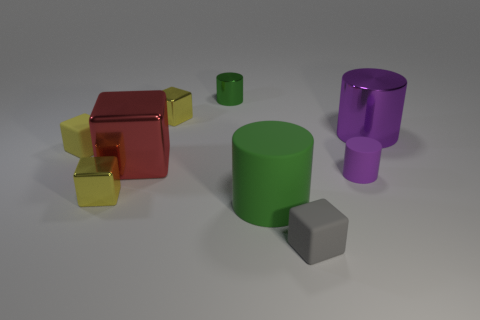What is the material of the other cylinder that is the same color as the large rubber cylinder? metal 